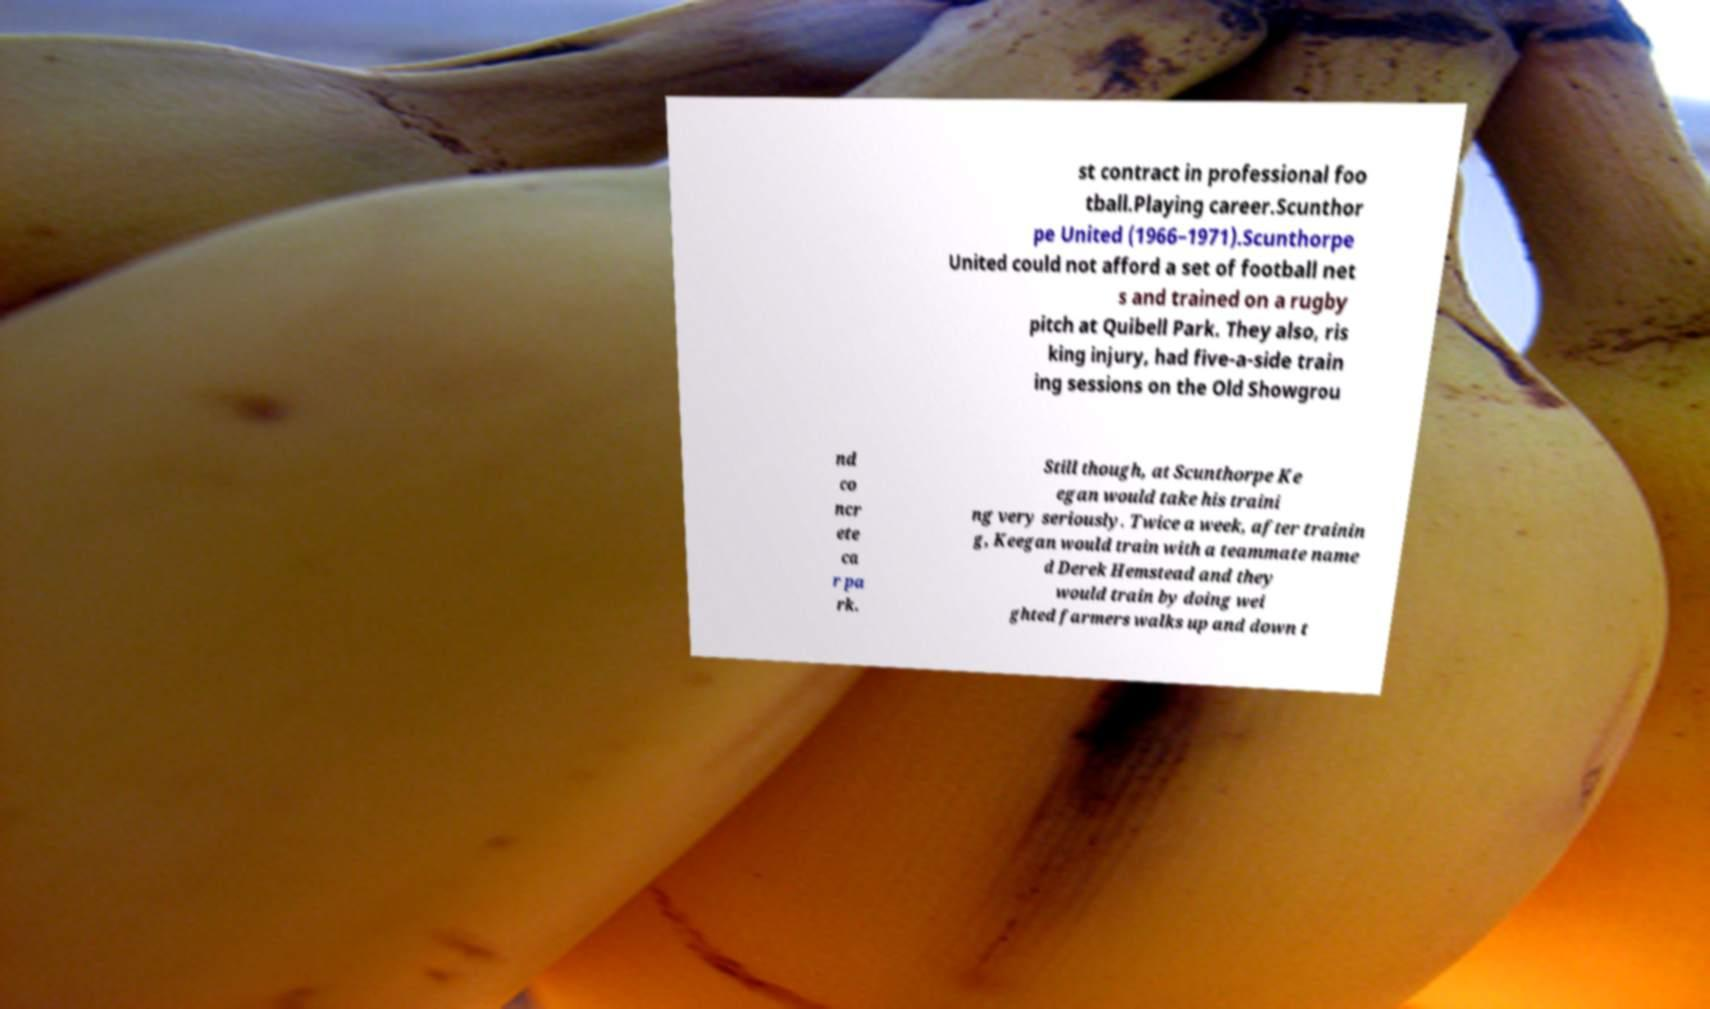There's text embedded in this image that I need extracted. Can you transcribe it verbatim? st contract in professional foo tball.Playing career.Scunthor pe United (1966–1971).Scunthorpe United could not afford a set of football net s and trained on a rugby pitch at Quibell Park. They also, ris king injury, had five-a-side train ing sessions on the Old Showgrou nd co ncr ete ca r pa rk. Still though, at Scunthorpe Ke egan would take his traini ng very seriously. Twice a week, after trainin g, Keegan would train with a teammate name d Derek Hemstead and they would train by doing wei ghted farmers walks up and down t 